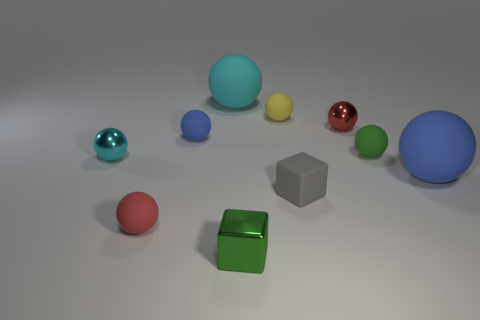Subtract all green blocks. How many cyan spheres are left? 2 Subtract all red metal spheres. How many spheres are left? 7 Subtract 4 balls. How many balls are left? 4 Subtract all cyan spheres. How many spheres are left? 6 Subtract all blocks. How many objects are left? 8 Subtract all gray cubes. Subtract all yellow cylinders. How many cubes are left? 1 Subtract all large rubber cylinders. Subtract all matte cubes. How many objects are left? 9 Add 8 tiny blocks. How many tiny blocks are left? 10 Add 7 green cylinders. How many green cylinders exist? 7 Subtract 1 green balls. How many objects are left? 9 